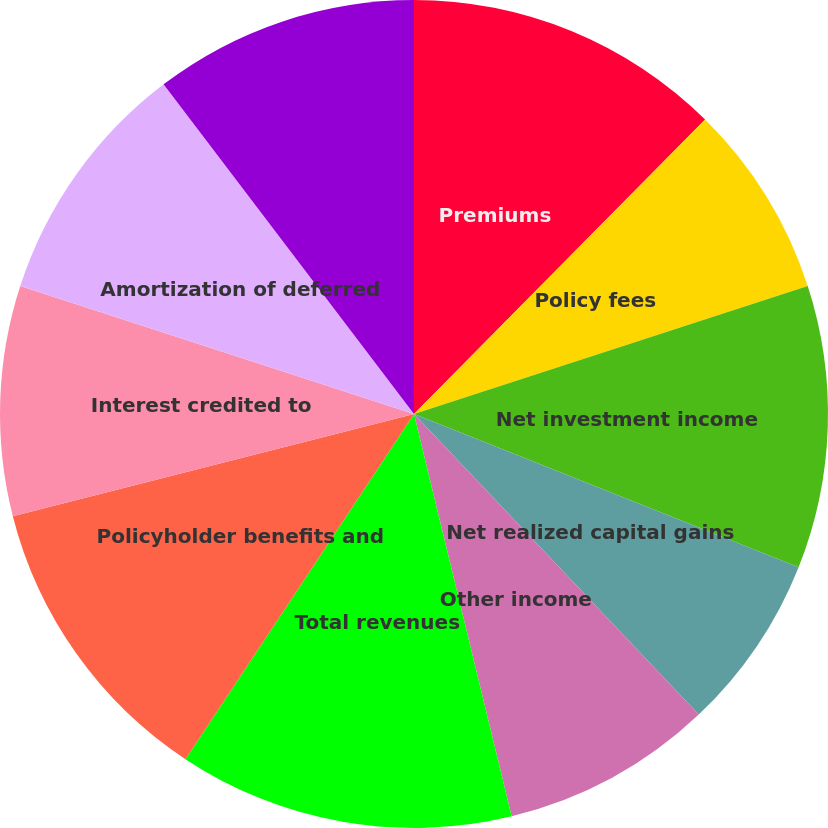Convert chart to OTSL. <chart><loc_0><loc_0><loc_500><loc_500><pie_chart><fcel>Premiums<fcel>Policy fees<fcel>Net investment income<fcel>Net realized capital gains<fcel>Other income<fcel>Total revenues<fcel>Policyholder benefits and<fcel>Interest credited to<fcel>Amortization of deferred<fcel>General operating and other<nl><fcel>12.41%<fcel>7.59%<fcel>11.03%<fcel>6.9%<fcel>8.28%<fcel>13.1%<fcel>11.72%<fcel>8.97%<fcel>9.66%<fcel>10.34%<nl></chart> 